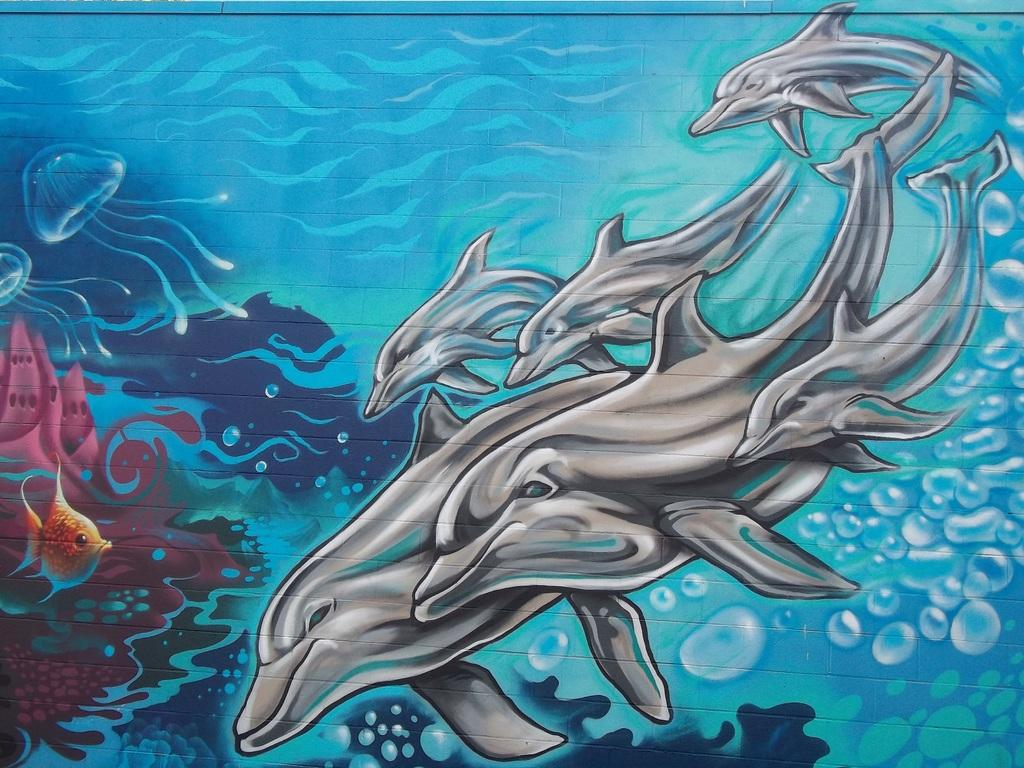What is depicted on the wall in the image? There is a painting on the wall in the image. What animals are featured in the painting? The painting contains fishes and dolphins. How many ducks are swimming in the painting? There are no ducks present in the painting; it features fishes and dolphins. What arm is visible in the painting? There are no arms visible in the painting; it is a painting of marine animals. 